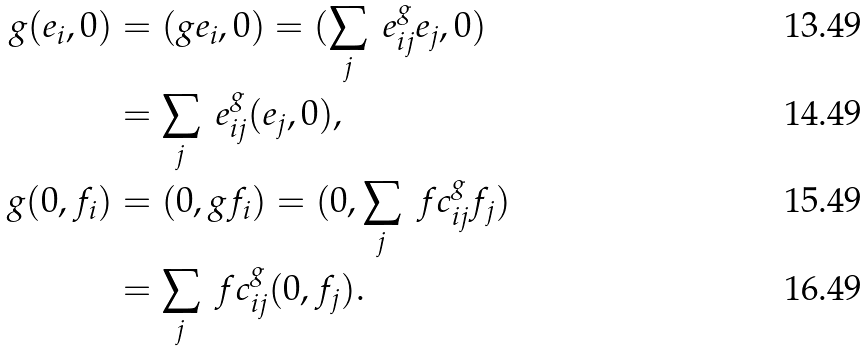<formula> <loc_0><loc_0><loc_500><loc_500>g ( e _ { i } , 0 ) & = ( g e _ { i } , 0 ) = ( \sum _ { j } \ e ^ { g } _ { i j } e _ { j } , 0 ) \\ & = \sum _ { j } \ e ^ { g } _ { i j } ( e _ { j } , 0 ) , \\ g ( 0 , f _ { i } ) & = ( 0 , g f _ { i } ) = ( 0 , \sum _ { j } \ f c ^ { g } _ { i j } f _ { j } ) \\ & = \sum _ { j } \ f c ^ { g } _ { i j } ( 0 , f _ { j } ) .</formula> 